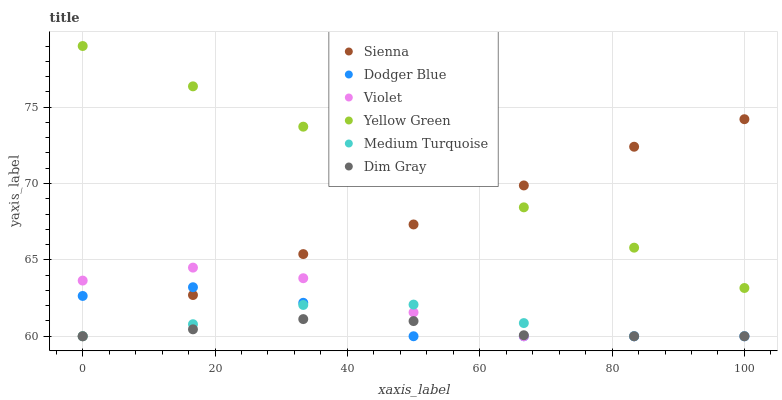Does Dim Gray have the minimum area under the curve?
Answer yes or no. Yes. Does Yellow Green have the maximum area under the curve?
Answer yes or no. Yes. Does Sienna have the minimum area under the curve?
Answer yes or no. No. Does Sienna have the maximum area under the curve?
Answer yes or no. No. Is Yellow Green the smoothest?
Answer yes or no. Yes. Is Violet the roughest?
Answer yes or no. Yes. Is Sienna the smoothest?
Answer yes or no. No. Is Sienna the roughest?
Answer yes or no. No. Does Dim Gray have the lowest value?
Answer yes or no. Yes. Does Yellow Green have the lowest value?
Answer yes or no. No. Does Yellow Green have the highest value?
Answer yes or no. Yes. Does Sienna have the highest value?
Answer yes or no. No. Is Dim Gray less than Yellow Green?
Answer yes or no. Yes. Is Yellow Green greater than Dim Gray?
Answer yes or no. Yes. Does Dim Gray intersect Medium Turquoise?
Answer yes or no. Yes. Is Dim Gray less than Medium Turquoise?
Answer yes or no. No. Is Dim Gray greater than Medium Turquoise?
Answer yes or no. No. Does Dim Gray intersect Yellow Green?
Answer yes or no. No. 